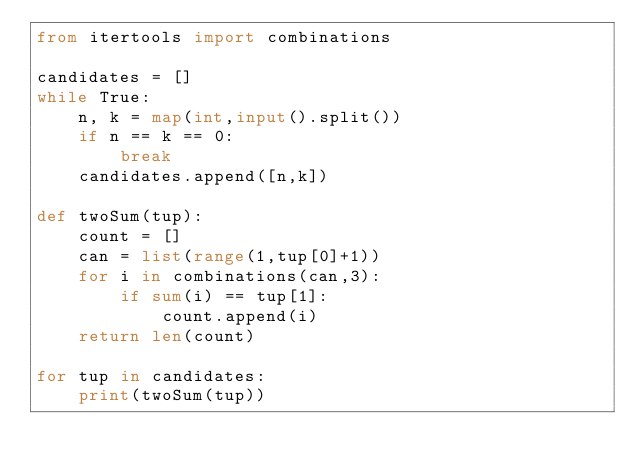Convert code to text. <code><loc_0><loc_0><loc_500><loc_500><_Python_>from itertools import combinations

candidates = []
while True:
    n, k = map(int,input().split())
    if n == k == 0:
        break
    candidates.append([n,k])

def twoSum(tup):
    count = []
    can = list(range(1,tup[0]+1))
    for i in combinations(can,3):
        if sum(i) == tup[1]:
            count.append(i)
    return len(count)

for tup in candidates:
    print(twoSum(tup))
</code> 